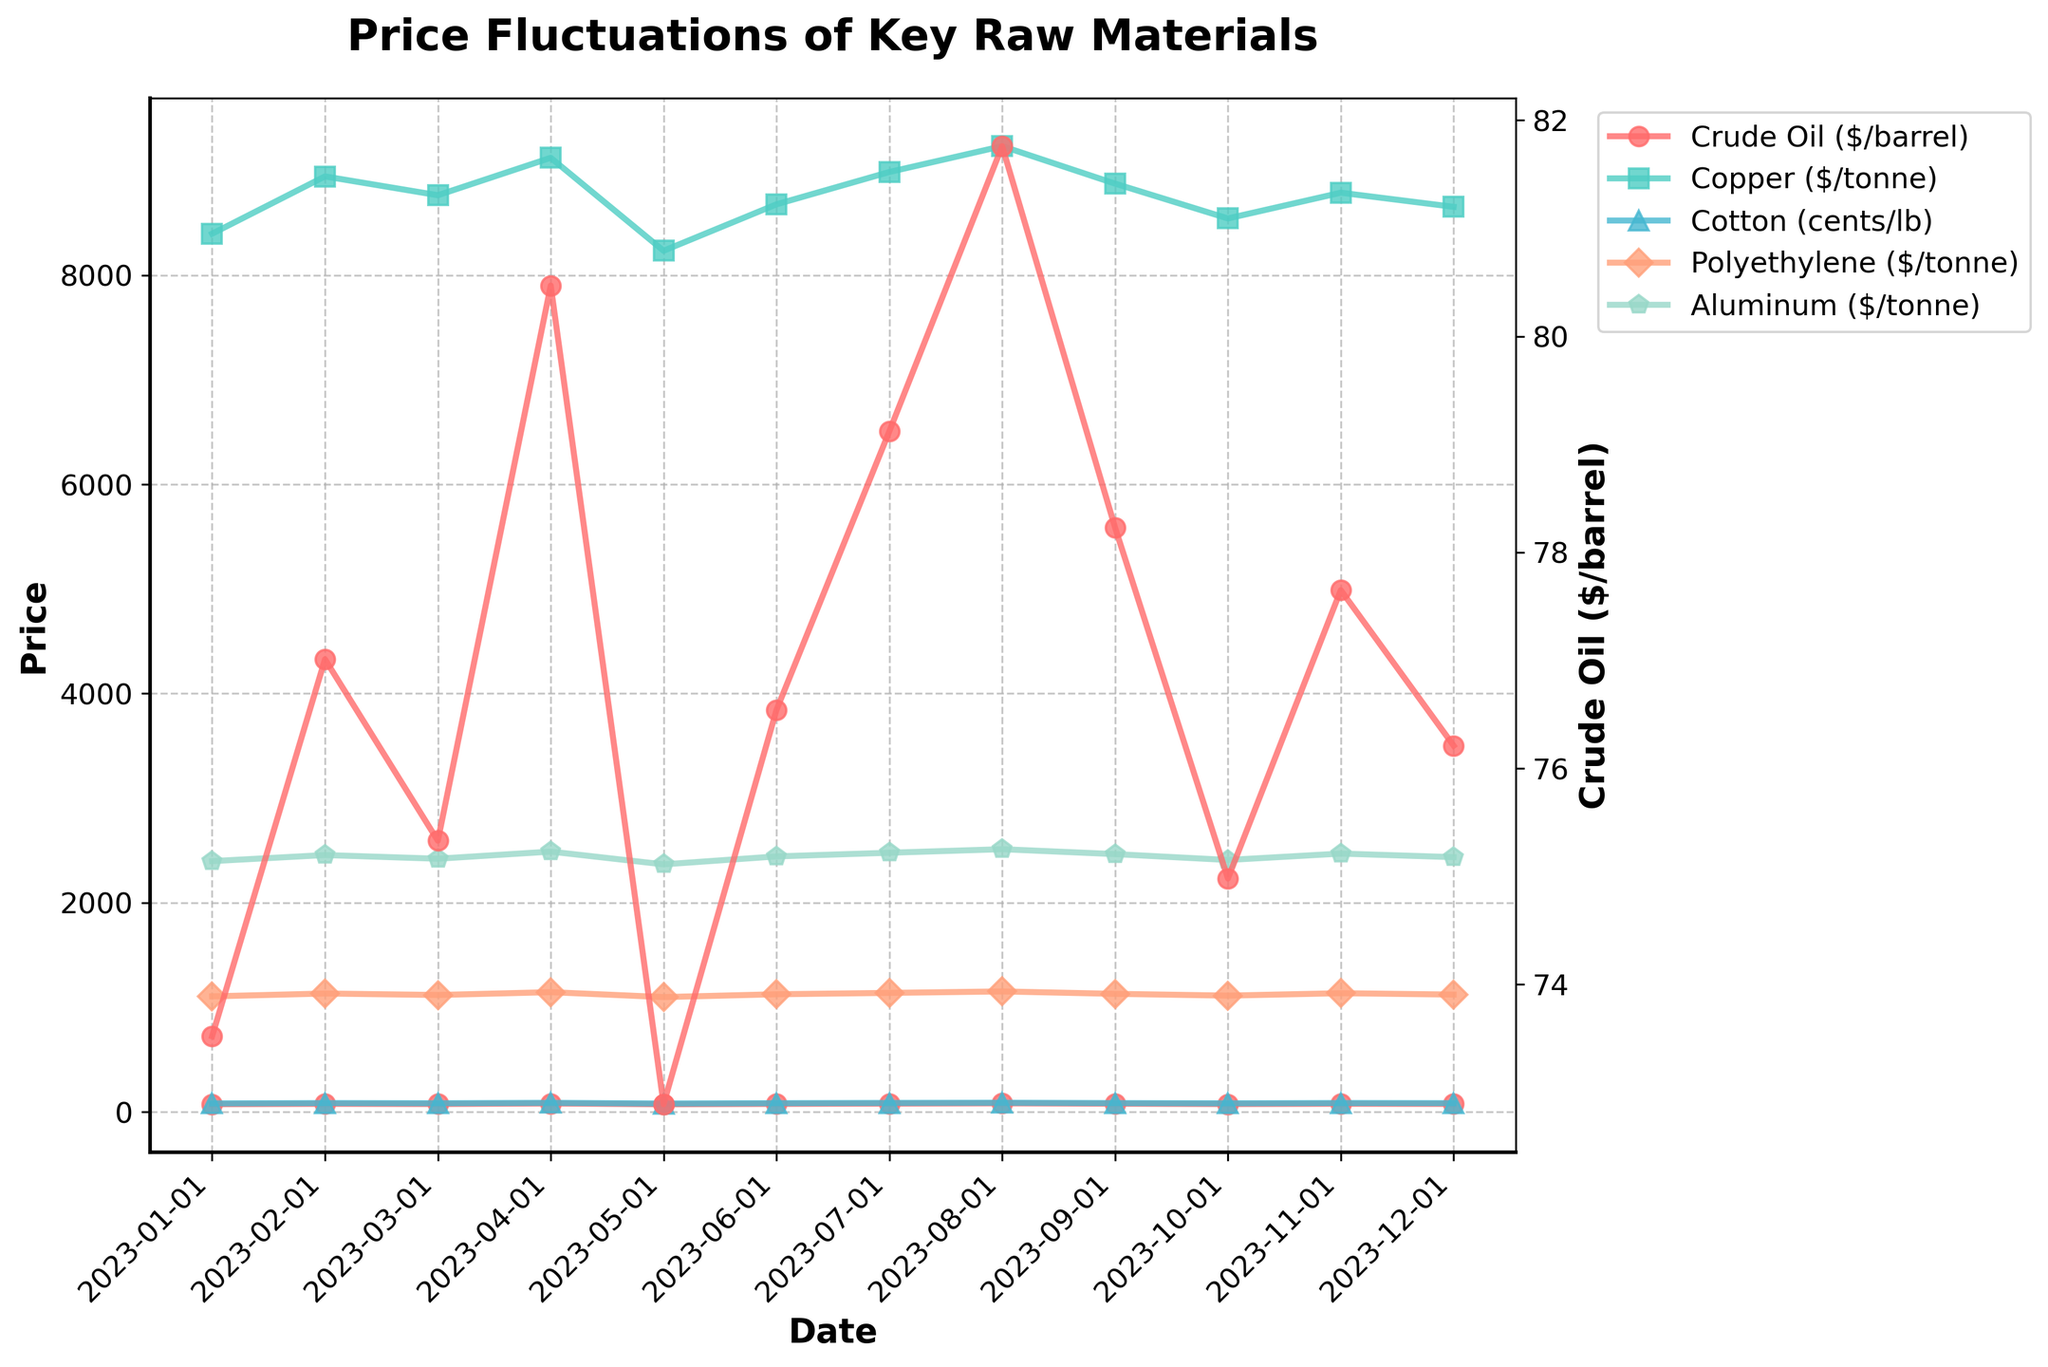What was the highest price of Crude Oil over the year? To determine the highest price, look at the peaks of the line corresponding to Crude Oil throughout all the months in the chart. The highest point is in April with a price of 80.47 $/barrel.
Answer: 80.47 $/barrel Which raw material had the greatest price fluctuation between January and December? To find the greatest price fluctuation, calculate the difference between the highest and lowest prices for each raw material over the year. Crude Oil oscillated between 72.89 $/barrel and 81.76 $/barrel, Copper between 8234 and 9234 $/tonne, Cotton between 80.15 and 87.65 cents/lb, Polyethylene between 1098 and 1152 $/tonne, and Aluminum between 2367 and 2512 $/tonne. Among these, Copper had the greatest fluctuation of 1000 $/tonne.
Answer: Copper Which months show a price increase for both Crude Oil and Cotton? Identify the months where both Crude Oil and Cotton prices increased compared to the previous month. These months are February, April, and August.
Answer: February, April, August During which month did Polyethylene have its lowest price? To find this, look for the lowest point on the line representing Polyethylene prices within the months shown. The lowest price for Polyethylene was in May with a price of 1098 $/tonne.
Answer: May What is the average price of Aluminum over the year? Sum up all the Aluminum prices for each month and divide by the number of months. (2398 + 2456 + 2421 + 2489 + 2367 + 2443 + 2478 + 2512 + 2465 + 2409 + 2470 + 2436)/12 months = 2437.25 $/tonne.
Answer: 2437.25 $/tonne In which months did all raw materials (except Crude Oil) show a decrease in price from the previous month? For each month, check if all raw materials (except Crude Oil) showed a decrease in price compared to the previous month. This happened in October.
Answer: October How did the price of Cotton change from the beginning to the end of the year? Compare the Cotton price in January (81.23 cents/lb) with the price in December (83.75 cents/lb). The price increased by 2.52 cents/lb over the year.
Answer: Increase by 2.52 cents/lb Which raw material had the most steady price over the year? Evaluate the fluctuations for each raw material by noting the price peaks and troughs. Polyethylene shows the most steady price change as it varies the least from month to month.
Answer: Polyethylene 